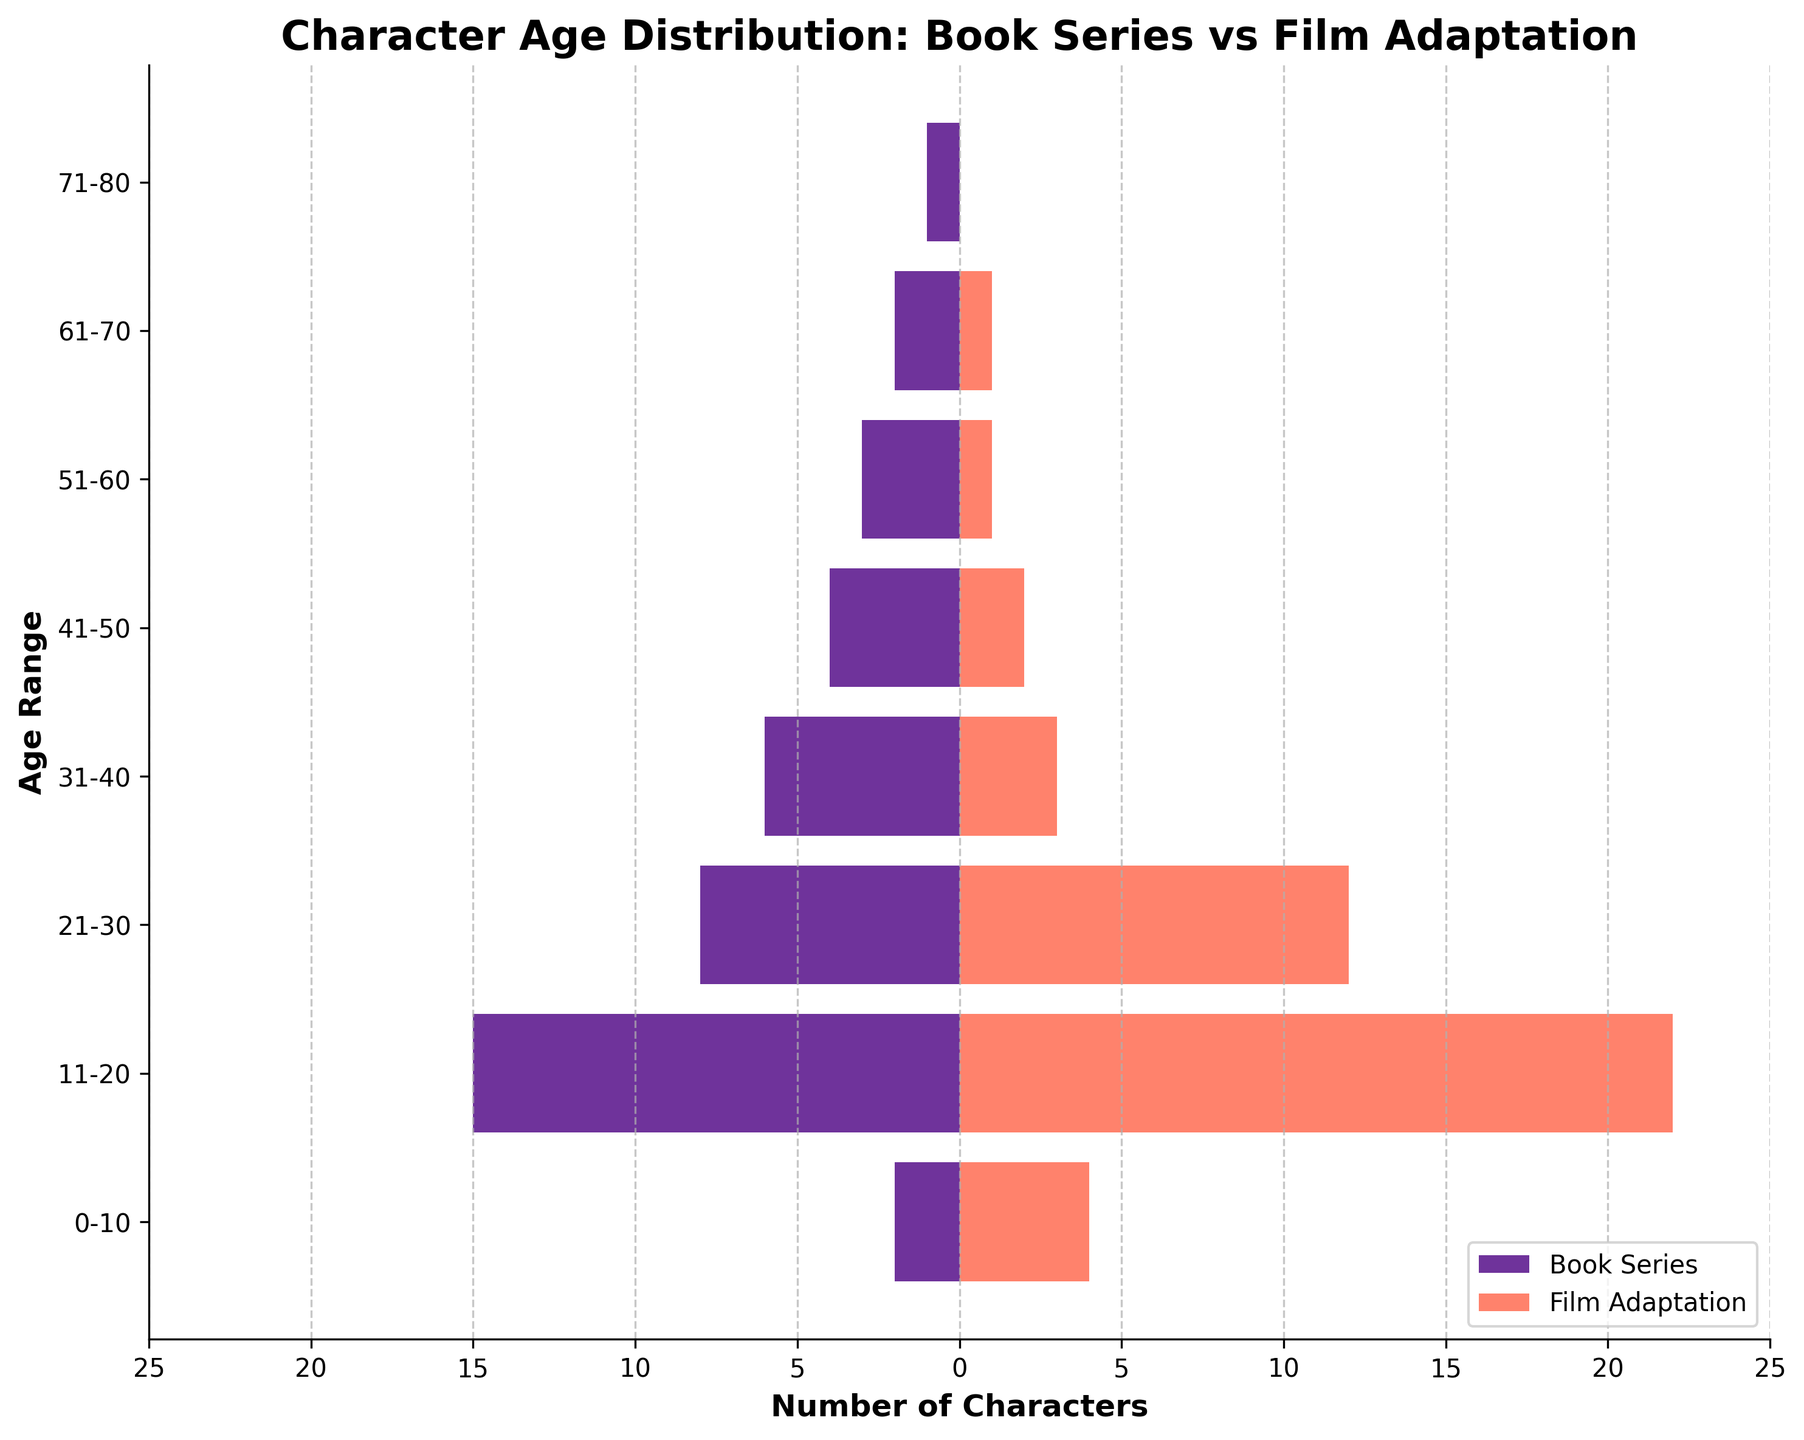What are the two age ranges with the highest number of characters in the film adaptation? To find the two age ranges with the highest number of characters in the film adaptation, look at the lengths of the orange bars. The 11-20 age range has 22 characters, and the 21-30 age range has 12 characters.
Answer: 11-20 and 21-30 Which age range has the most pronounced difference in character numbers between the book series and film adaptation? To identify the age range with the most pronounced difference, compare the lengths of the corresponding bars for each age range. The 11-20 age range has the largest difference, with 15 in the book series and 22 in the film adaptation, a difference of 7 characters.
Answer: 11-20 How many total characters are there in the 31-40 age range across both book series and film adaptations? Add the number of characters in the 31-40 age range for both the book series (6) and the film adaptations (3). So, 6 + 3 = 9.
Answer: 9 In the book series, which age range has the fewest characters, and how many characters are there in that range? The age range with the fewest characters in the book series can be identified by the shortest purple bar. The 71-80 age range has the fewest characters with 1.
Answer: 71-80, 1 Are there any age ranges where the film adaptation has no characters while the book series does? Check for any age ranges with an orange bar length of zero and a non-zero purple bar. The 71-80 age range has 1 character in the book series and 0 in the film adaptation.
Answer: 71-80 How many more characters are in the 41-50 age range in the book series compared to the film adaptation? Subtract the number of characters in the 41-50 age range in the film adaptation (2) from the number in the book series (4). So, 4 - 2 = 2.
Answer: 2 Which age range shows the least number of characters in both book series and film adaptations combined? Look for the age range where both the purple and orange bars are shortest. The 71-80 age range has a total of 1 character (1 in book series and 0 in film adaptation).
Answer: 71-80 How many characters aged 51-60 are there in both the book series and film adaptations combined? Add the number of characters in the 51-60 age range for both the book series (3) and the film adaptations (1). So, 3 + 1 = 4 characters.
Answer: 4 Is there an age range where the film adaptation added more than twice the number of characters compared to the book series? If so, which one? Compare the relative differences for each range. The 0-10 age range has 2 characters in the book series and 4 in the film adaptation, which is exactly twice but not more than twice. Therefore, there are no age ranges where the film added more than twice the number of characters.
Answer: No 